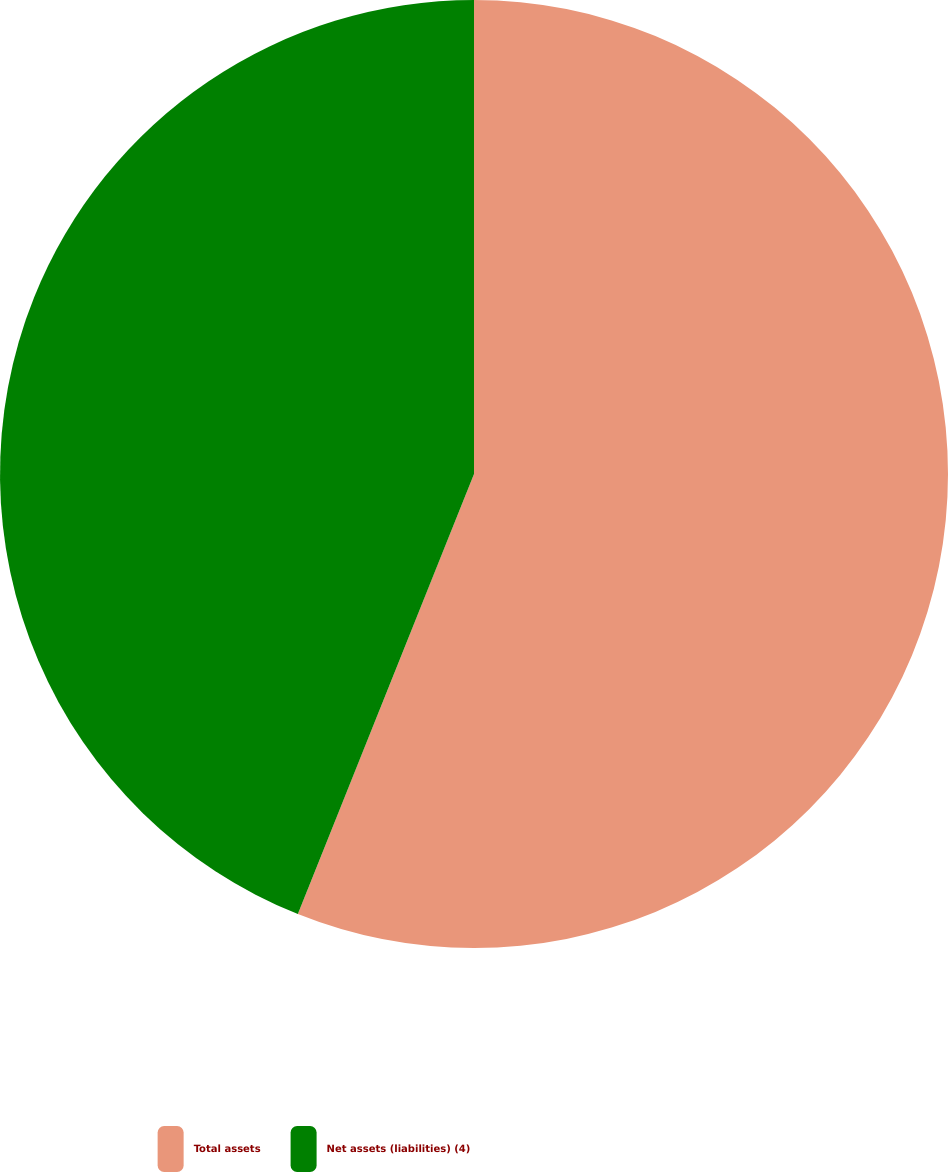Convert chart to OTSL. <chart><loc_0><loc_0><loc_500><loc_500><pie_chart><fcel>Total assets<fcel>Net assets (liabilities) (4)<nl><fcel>56.06%<fcel>43.94%<nl></chart> 